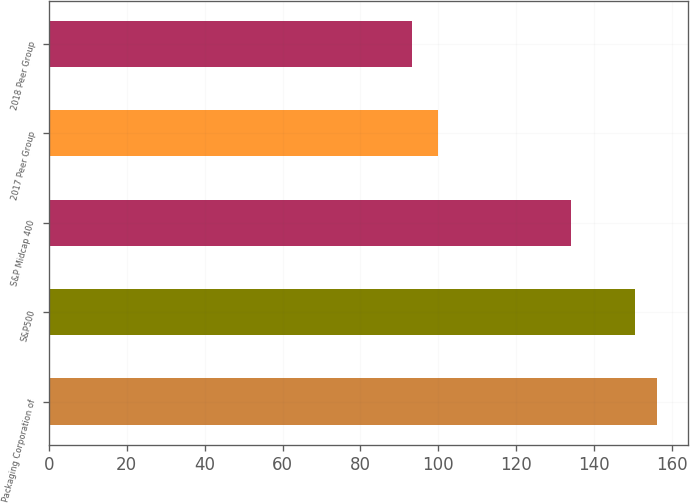Convert chart to OTSL. <chart><loc_0><loc_0><loc_500><loc_500><bar_chart><fcel>Packaging Corporation of<fcel>S&P500<fcel>S&P Midcap 400<fcel>2017 Peer Group<fcel>2018 Peer Group<nl><fcel>156.15<fcel>150.33<fcel>134.01<fcel>99.79<fcel>93.2<nl></chart> 